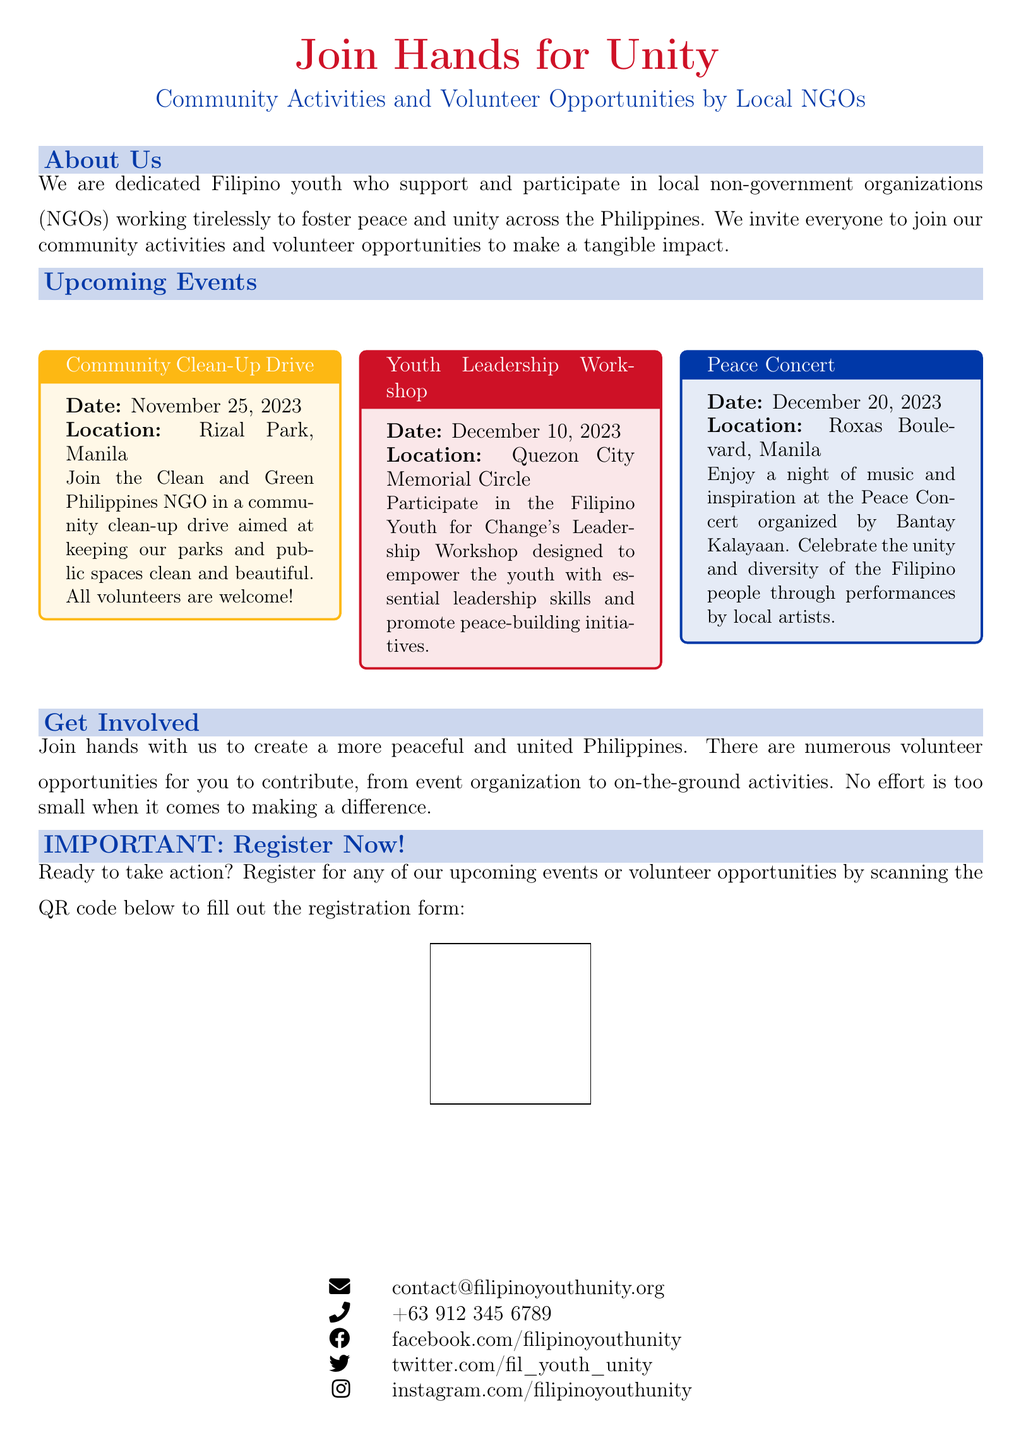What is the title of the advertisement? The title indicates the main focus of the advertisement, which is "Join Hands for Unity".
Answer: Join Hands for Unity When is the Community Clean-Up Drive event scheduled? The date provided in the document tells when this event will take place, which is November 25, 2023.
Answer: November 25, 2023 Where will the Youth Leadership Workshop be held? The location mentioned for this event is crucial for participants to know where to go, which is Quezon City Memorial Circle.
Answer: Quezon City Memorial Circle What organization is responsible for the Peace Concert? This question focuses on identifying the NGO that organizes the respective event mentioned in the document.
Answer: Bantay Kalayaan What is the age group targeted by the Youth Leadership Workshop? This question assesses understanding from the advertisement context, recognizing that the event is for the youth.
Answer: Youth How can interested individuals register for the events? The document states a clear action step for registration, focusing on the QR code as the registration method.
Answer: QR code What is the contact email provided for inquiries? The document includes a specific email address for people to reach out with any questions.
Answer: contact@filipinoyouthunity.org What type of activities does the advertisement promote? This focuses on the main theme of the document—what kind of community engagement is advocated.
Answer: Volunteer opportunities How many upcoming events are listed in the document? This assesses the reader's ability to count the distinct events mentioned in the advertisement.
Answer: Three 